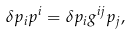Convert formula to latex. <formula><loc_0><loc_0><loc_500><loc_500>\delta p _ { i } p ^ { i } = \delta p _ { i } g ^ { i j } p _ { j } ,</formula> 